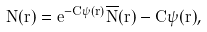<formula> <loc_0><loc_0><loc_500><loc_500>N ( r ) = e ^ { - C \psi ( r ) } \overline { N } ( r ) - C \psi ( r ) ,</formula> 